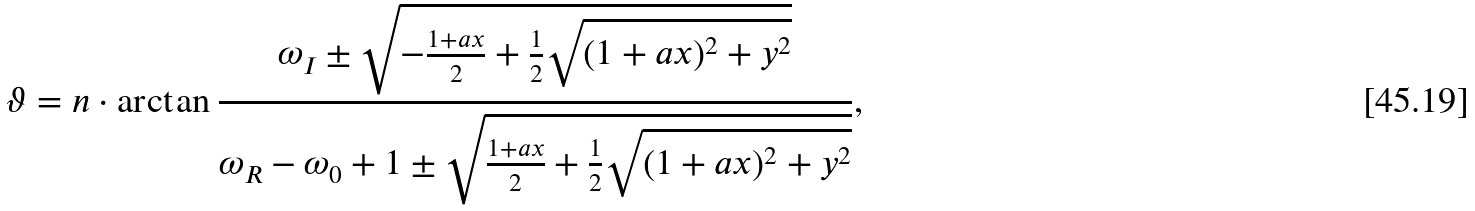Convert formula to latex. <formula><loc_0><loc_0><loc_500><loc_500>\vartheta = n \cdot \arctan \frac { \omega _ { I } \pm \sqrt { \strut { - \frac { 1 + a x } { 2 } + \frac { 1 } { 2 } \sqrt { \strut { ( 1 + a x ) ^ { 2 } + y ^ { 2 } } } } } } { \omega _ { R } - \omega _ { 0 } + 1 \pm \sqrt { \strut { \frac { 1 + a x } { 2 } + \frac { 1 } { 2 } \sqrt { \strut { ( 1 + a x ) ^ { 2 } + y ^ { 2 } } } } } } ,</formula> 